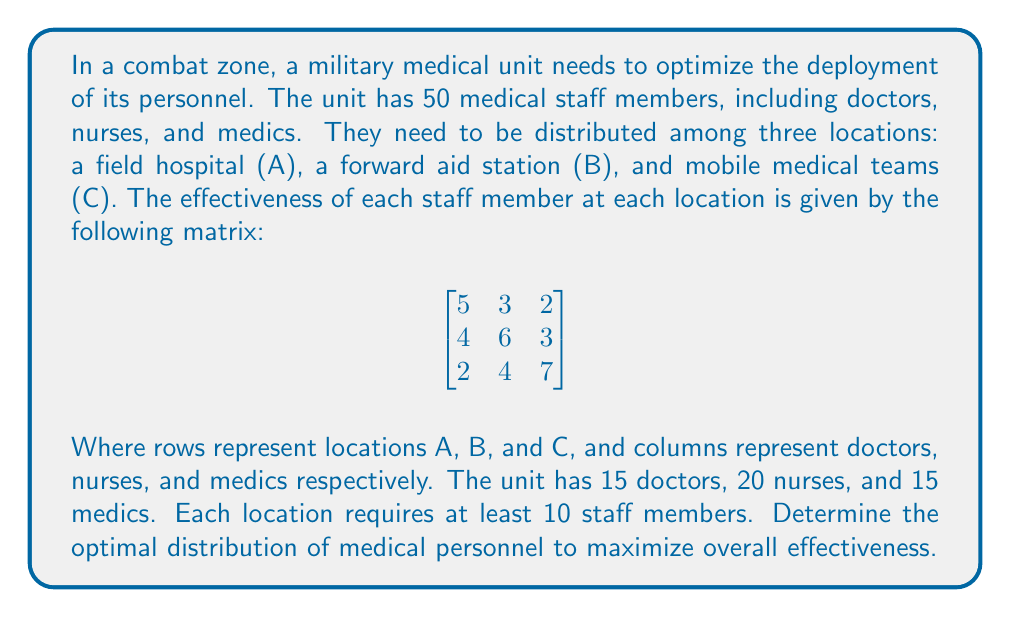Solve this math problem. This problem can be solved using linear programming. Let's define our variables:

$x_1, x_2, x_3$: number of doctors at locations A, B, and C
$y_1, y_2, y_3$: number of nurses at locations A, B, and C
$z_1, z_2, z_3$: number of medics at locations A, B, and C

Objective function:
$$\text{Maximize } 5x_1 + 3y_1 + 2z_1 + 4x_2 + 6y_2 + 3z_2 + 2x_3 + 4y_3 + 7z_3$$

Constraints:
1. Total number of each type of staff:
   $x_1 + x_2 + x_3 = 15$
   $y_1 + y_2 + y_3 = 20$
   $z_1 + z_2 + z_3 = 15$

2. Minimum staff at each location:
   $x_1 + y_1 + z_1 \geq 10$
   $x_2 + y_2 + z_2 \geq 10$
   $x_3 + y_3 + z_3 \geq 10$

3. Non-negativity:
   $x_1, x_2, x_3, y_1, y_2, y_3, z_1, z_2, z_3 \geq 0$

Using a linear programming solver, we find the optimal solution:

Location A: 10 doctors, 0 nurses, 0 medics
Location B: 5 doctors, 20 nurses, 0 medics
Location C: 0 doctors, 0 nurses, 15 medics

This distribution maximizes the overall effectiveness.
Answer: The optimal distribution is:
Location A (Field Hospital): 10 doctors, 0 nurses, 0 medics
Location B (Forward Aid Station): 5 doctors, 20 nurses, 0 medics
Location C (Mobile Medical Teams): 0 doctors, 0 nurses, 15 medics

Maximum effectiveness: $5(10) + 4(5) + 6(20) + 7(15) = 265$ 